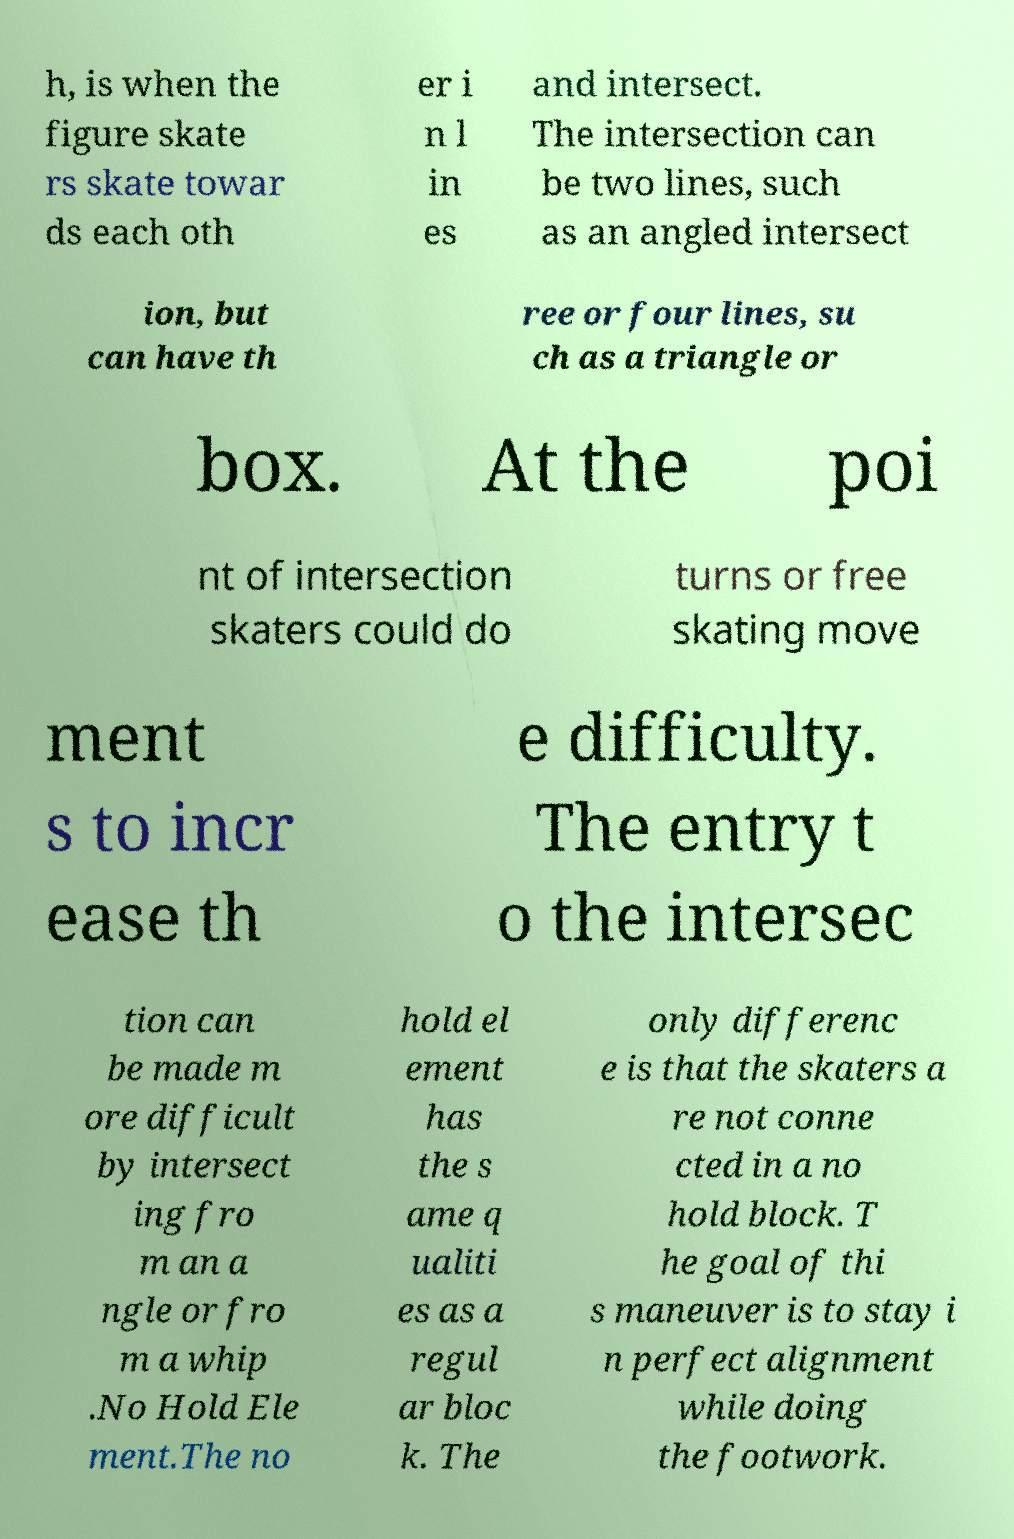There's text embedded in this image that I need extracted. Can you transcribe it verbatim? h, is when the figure skate rs skate towar ds each oth er i n l in es and intersect. The intersection can be two lines, such as an angled intersect ion, but can have th ree or four lines, su ch as a triangle or box. At the poi nt of intersection skaters could do turns or free skating move ment s to incr ease th e difficulty. The entry t o the intersec tion can be made m ore difficult by intersect ing fro m an a ngle or fro m a whip .No Hold Ele ment.The no hold el ement has the s ame q ualiti es as a regul ar bloc k. The only differenc e is that the skaters a re not conne cted in a no hold block. T he goal of thi s maneuver is to stay i n perfect alignment while doing the footwork. 